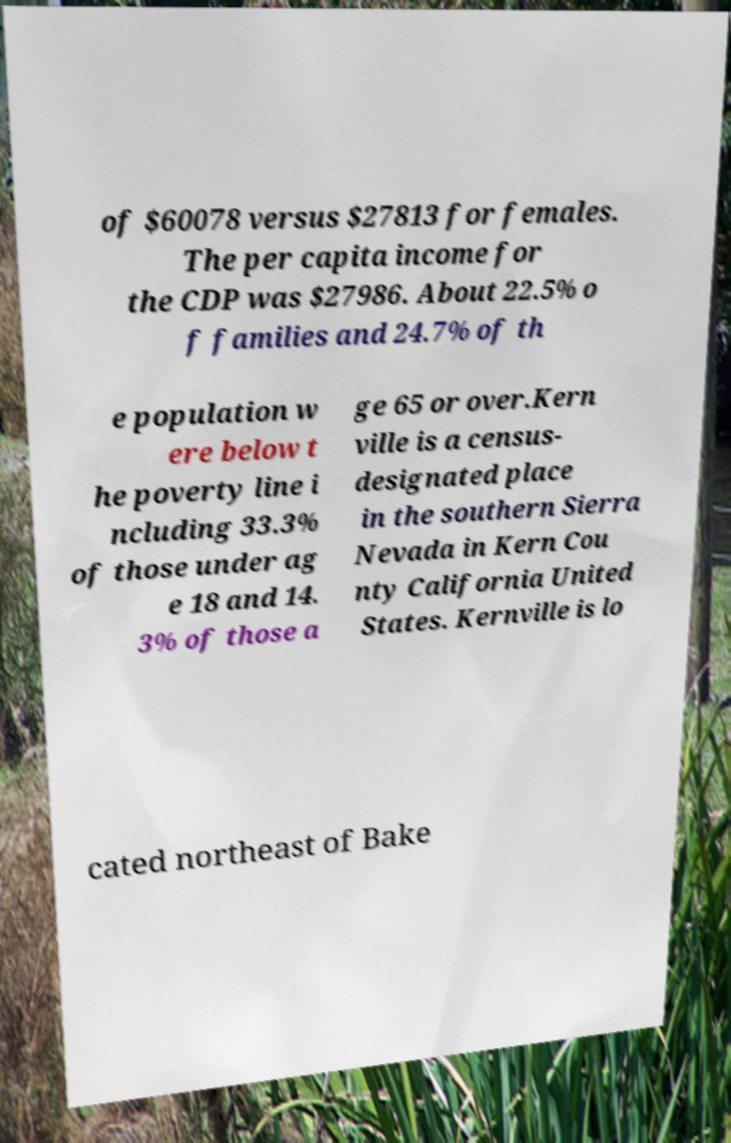Please read and relay the text visible in this image. What does it say? of $60078 versus $27813 for females. The per capita income for the CDP was $27986. About 22.5% o f families and 24.7% of th e population w ere below t he poverty line i ncluding 33.3% of those under ag e 18 and 14. 3% of those a ge 65 or over.Kern ville is a census- designated place in the southern Sierra Nevada in Kern Cou nty California United States. Kernville is lo cated northeast of Bake 